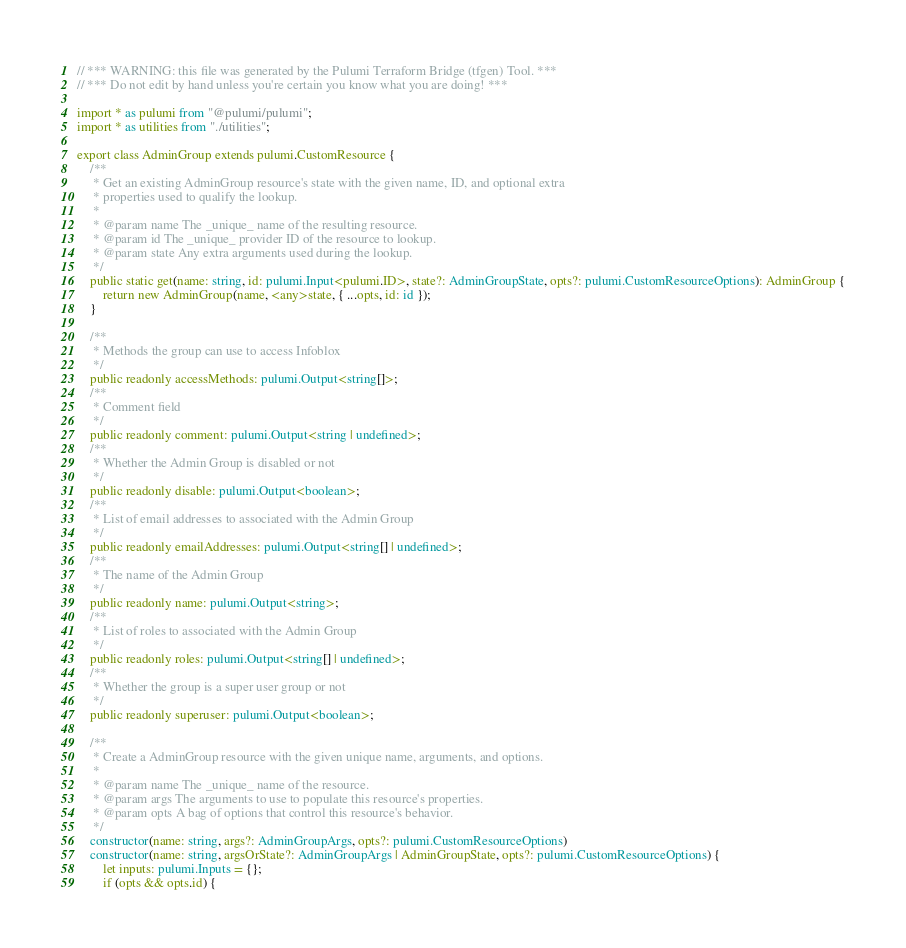Convert code to text. <code><loc_0><loc_0><loc_500><loc_500><_TypeScript_>// *** WARNING: this file was generated by the Pulumi Terraform Bridge (tfgen) Tool. ***
// *** Do not edit by hand unless you're certain you know what you are doing! ***

import * as pulumi from "@pulumi/pulumi";
import * as utilities from "./utilities";

export class AdminGroup extends pulumi.CustomResource {
    /**
     * Get an existing AdminGroup resource's state with the given name, ID, and optional extra
     * properties used to qualify the lookup.
     *
     * @param name The _unique_ name of the resulting resource.
     * @param id The _unique_ provider ID of the resource to lookup.
     * @param state Any extra arguments used during the lookup.
     */
    public static get(name: string, id: pulumi.Input<pulumi.ID>, state?: AdminGroupState, opts?: pulumi.CustomResourceOptions): AdminGroup {
        return new AdminGroup(name, <any>state, { ...opts, id: id });
    }

    /**
     * Methods the group can use to access Infoblox
     */
    public readonly accessMethods: pulumi.Output<string[]>;
    /**
     * Comment field
     */
    public readonly comment: pulumi.Output<string | undefined>;
    /**
     * Whether the Admin Group is disabled or not
     */
    public readonly disable: pulumi.Output<boolean>;
    /**
     * List of email addresses to associated with the Admin Group
     */
    public readonly emailAddresses: pulumi.Output<string[] | undefined>;
    /**
     * The name of the Admin Group
     */
    public readonly name: pulumi.Output<string>;
    /**
     * List of roles to associated with the Admin Group
     */
    public readonly roles: pulumi.Output<string[] | undefined>;
    /**
     * Whether the group is a super user group or not
     */
    public readonly superuser: pulumi.Output<boolean>;

    /**
     * Create a AdminGroup resource with the given unique name, arguments, and options.
     *
     * @param name The _unique_ name of the resource.
     * @param args The arguments to use to populate this resource's properties.
     * @param opts A bag of options that control this resource's behavior.
     */
    constructor(name: string, args?: AdminGroupArgs, opts?: pulumi.CustomResourceOptions)
    constructor(name: string, argsOrState?: AdminGroupArgs | AdminGroupState, opts?: pulumi.CustomResourceOptions) {
        let inputs: pulumi.Inputs = {};
        if (opts && opts.id) {</code> 